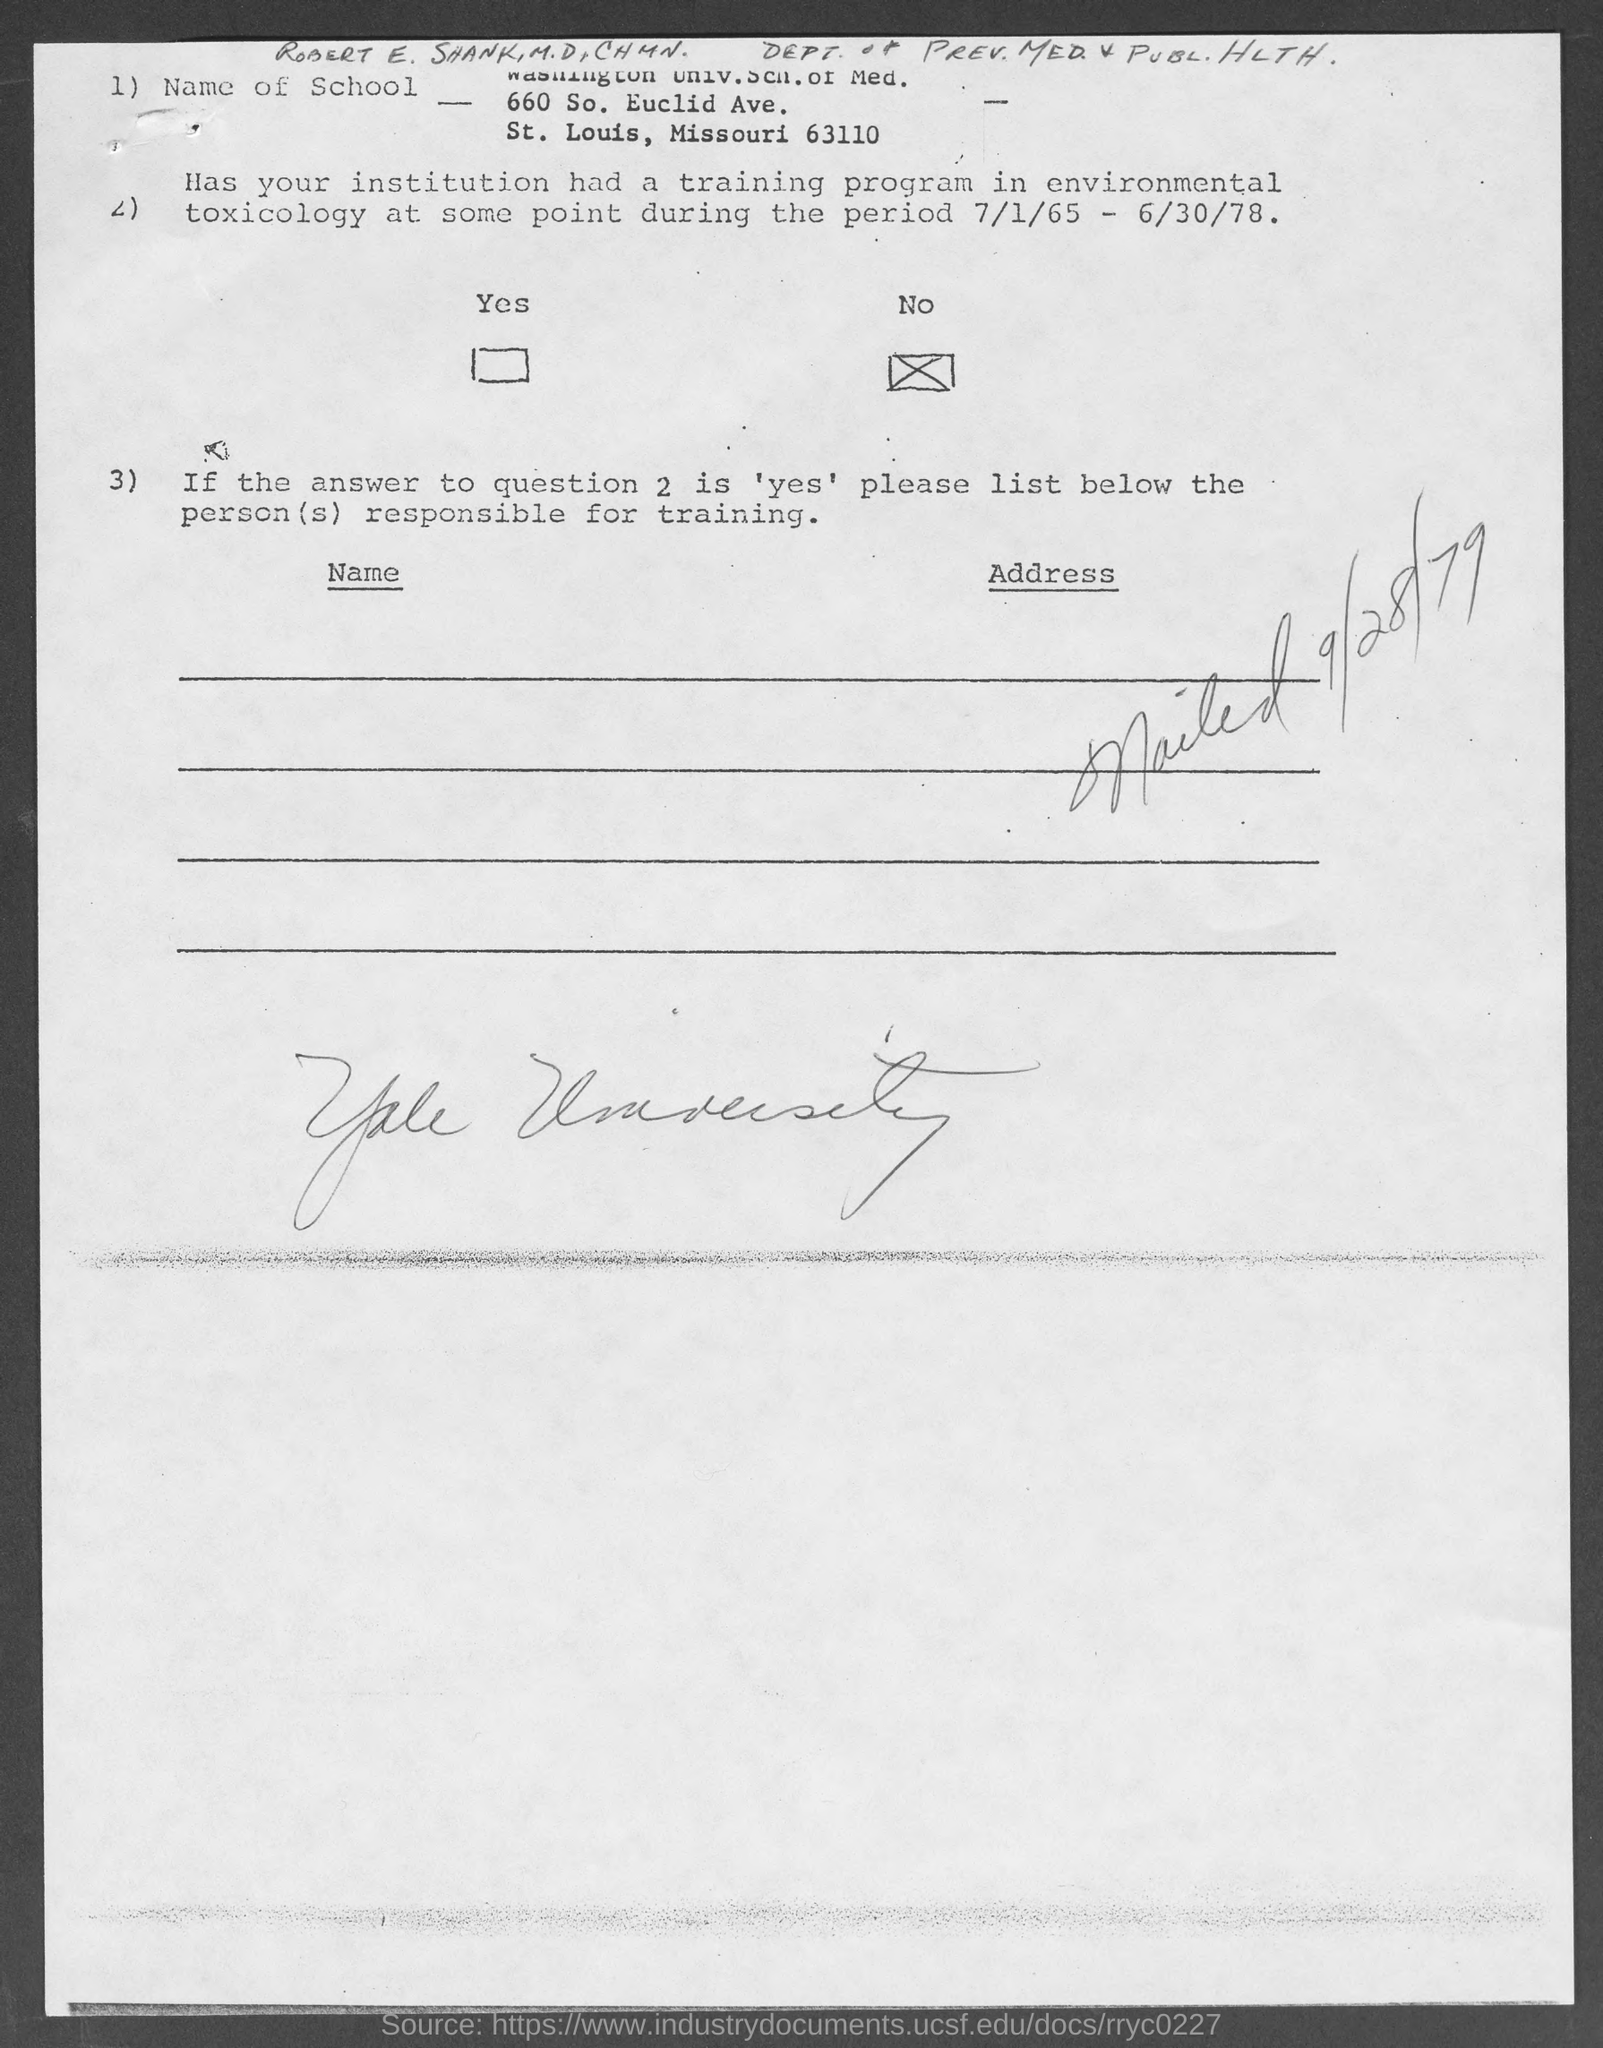When was it mailed?
Your response must be concise. 9/28/79. 